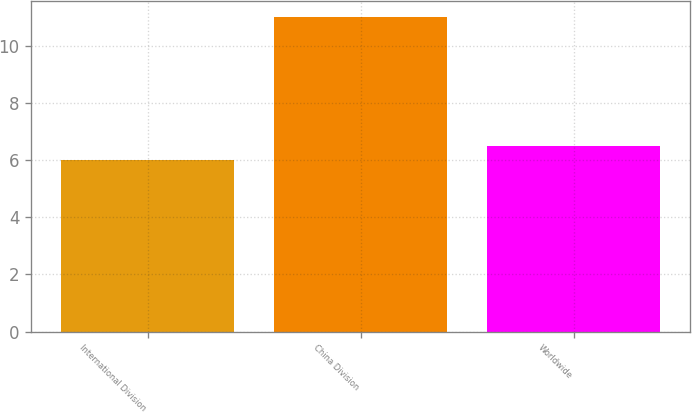Convert chart. <chart><loc_0><loc_0><loc_500><loc_500><bar_chart><fcel>International Division<fcel>China Division<fcel>Worldwide<nl><fcel>6<fcel>11<fcel>6.5<nl></chart> 